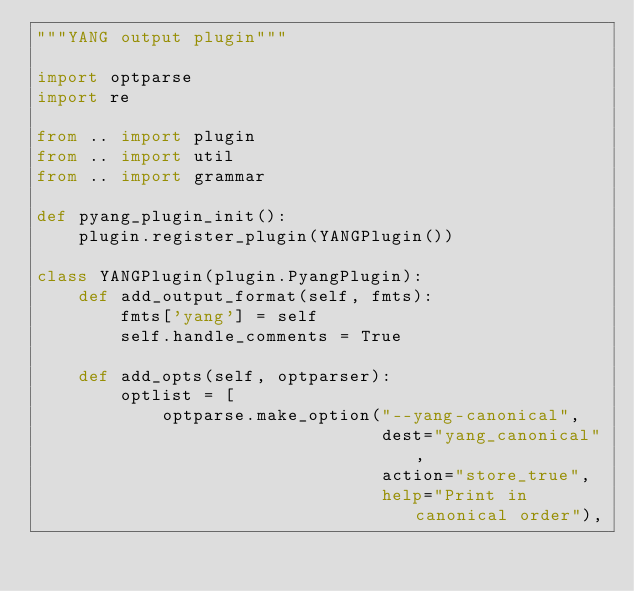<code> <loc_0><loc_0><loc_500><loc_500><_Python_>"""YANG output plugin"""

import optparse
import re

from .. import plugin
from .. import util
from .. import grammar

def pyang_plugin_init():
    plugin.register_plugin(YANGPlugin())

class YANGPlugin(plugin.PyangPlugin):
    def add_output_format(self, fmts):
        fmts['yang'] = self
        self.handle_comments = True

    def add_opts(self, optparser):
        optlist = [
            optparse.make_option("--yang-canonical",
                                 dest="yang_canonical",
                                 action="store_true",
                                 help="Print in canonical order"),</code> 